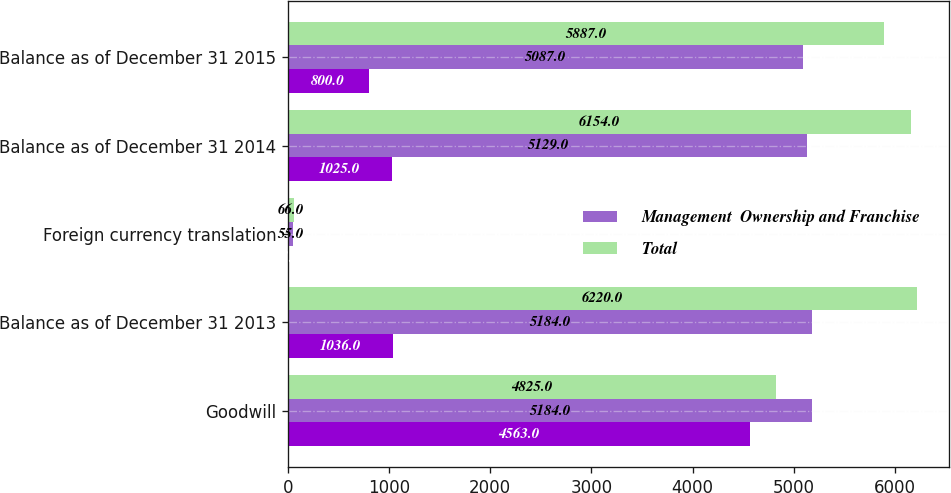<chart> <loc_0><loc_0><loc_500><loc_500><stacked_bar_chart><ecel><fcel>Goodwill<fcel>Balance as of December 31 2013<fcel>Foreign currency translation<fcel>Balance as of December 31 2014<fcel>Balance as of December 31 2015<nl><fcel>nan<fcel>4563<fcel>1036<fcel>11<fcel>1025<fcel>800<nl><fcel>Management  Ownership and Franchise<fcel>5184<fcel>5184<fcel>55<fcel>5129<fcel>5087<nl><fcel>Total<fcel>4825<fcel>6220<fcel>66<fcel>6154<fcel>5887<nl></chart> 